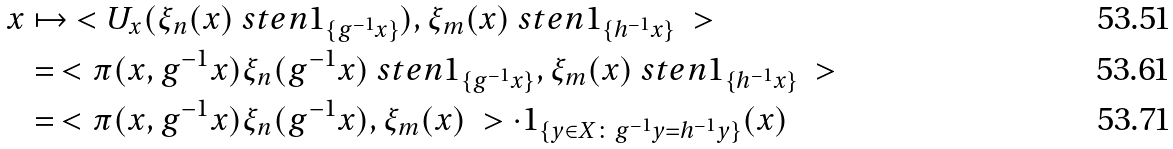<formula> <loc_0><loc_0><loc_500><loc_500>x & \mapsto \ < U _ { x } ( \xi _ { n } ( x ) \ s t e n 1 _ { \{ g ^ { - 1 } x \} } ) , \xi _ { m } ( x ) \ s t e n 1 _ { \{ h ^ { - 1 } x \} } \ > \\ & = \ < \pi ( x , g ^ { - 1 } x ) \xi _ { n } ( g ^ { - 1 } x ) \ s t e n 1 _ { \{ g ^ { - 1 } x \} } , \xi _ { m } ( x ) \ s t e n 1 _ { \{ h ^ { - 1 } x \} } \ > \\ & = \ < \pi ( x , g ^ { - 1 } x ) \xi _ { n } ( g ^ { - 1 } x ) , \xi _ { m } ( x ) \ > \cdot 1 _ { \{ y \in X \colon g ^ { - 1 } y = h ^ { - 1 } y \} } ( x )</formula> 